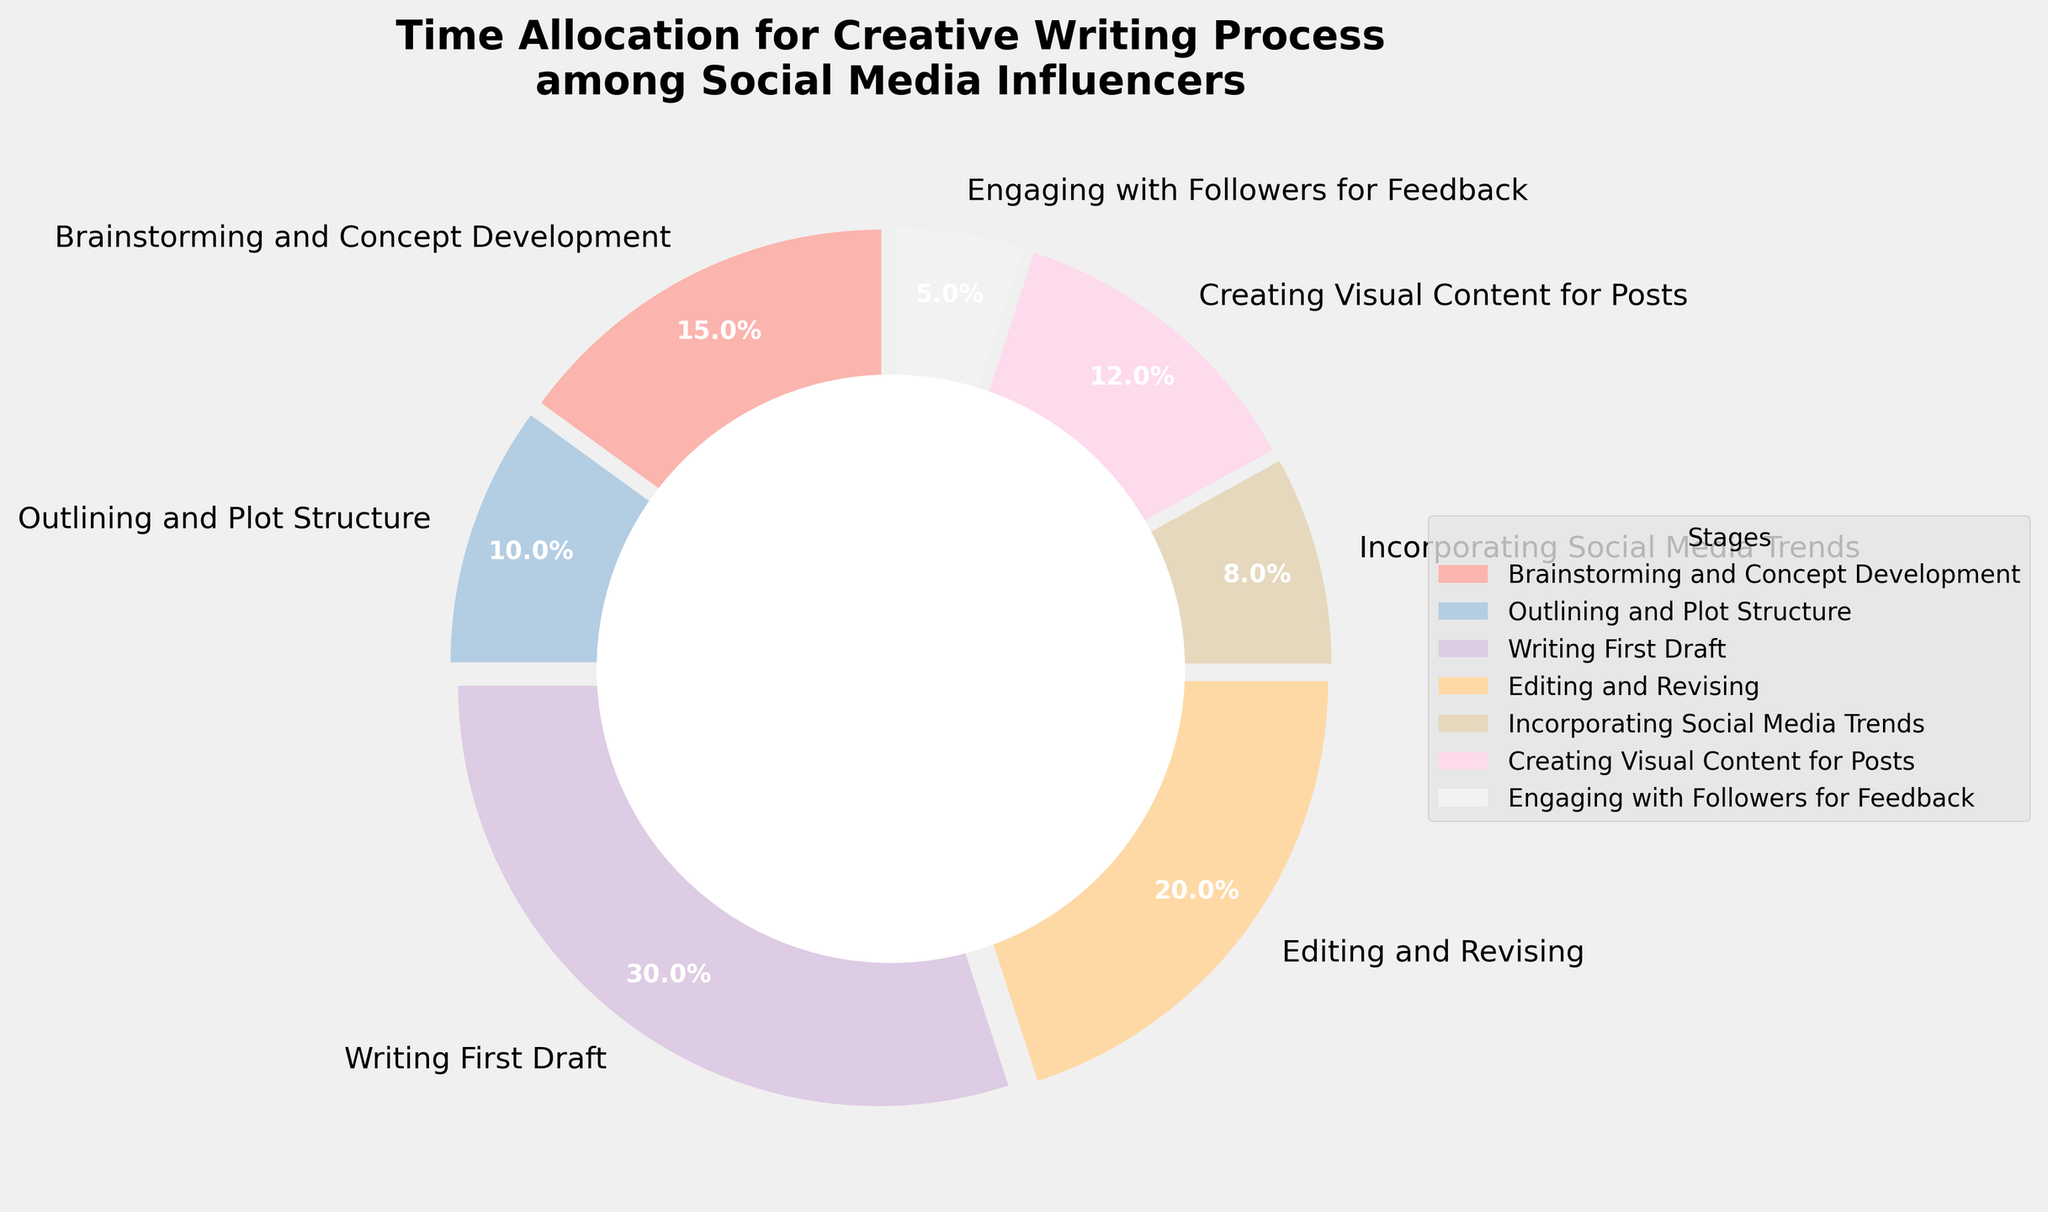Which stage takes up the largest percentage of time? To determine which stage takes up the largest percentage of time, look at the segment with the largest wedge in the pie chart. The Writing First Draft stage shows a percentage of 30%, making it the largest.
Answer: Writing First Draft Which stages together make up 50% of the time? Find two segments whose combined percentages equal 50%. Combining Editing and Revising (20%) with Brainstorming and Concept Development (15%) and Outlining and Plot Structure (10%) gives us 45%. Adding Engaging with Followers for Feedback (5%) brings it to a total of 50%.
Answer: Editing and Revising, Brainstorming and Concept Development, Outlining and Plot Structure, Engaging with Followers for Feedback Compare the time spent on Engaging with Followers for Feedback and Incorporating Social Media Trends. Which one takes more time? Look at the pie wedges corresponding to Engaging with Followers for Feedback (5%) and Incorporating Social Media Trends (8%). The wedge for Incorporating Social Media Trends is larger.
Answer: Incorporating Social Media Trends What's the percentage difference between Writing First Draft and Editing and Revising? Subtract the percentage of Editing and Revising (20%) from the percentage of Writing First Draft (30%). The difference is calculated as 30% - 20% = 10%.
Answer: 10% How much more time is spent on Creating Visual Content for Posts than on Outlining and Plot Structure? Subtract the time percentage of Outlining and Plot Structure (10%) from the percentage for Creating Visual Content for Posts (12%). This equals 12% - 10% = 2%.
Answer: 2% Is the time spent on Brainstorming and Concept Development greater than the combined time on Incorporating Social Media Trends and Engaging with Followers for Feedback? Add the percentages for Incorporating Social Media Trends (8%) and Engaging with Followers for Feedback (5%). This equals 8% + 5% = 13%. Compare this with Brainstorming and Concept Development (15%). Since 15% is greater than 13%, yes, it is greater.
Answer: Yes Which stages combined take up slightly over a third of the pie? To find stages that together make up slightly over one-third (around 33-34%), you can sum the percentages of Outlining and Plot Structure (10%), Incorporating Social Media Trends (8%), and Creating Visual Content for Posts (12%). Their combined total is 10% + 8% + 12% = 30%. Therefore, including Engaging with Followers for Feedback (5%) adds up to 35%, which is slightly over a third.
Answer: Outlining and Plot Structure, Incorporating Social Media Trends, Creating Visual Content for Posts, and Engaging with Followers for Feedback 